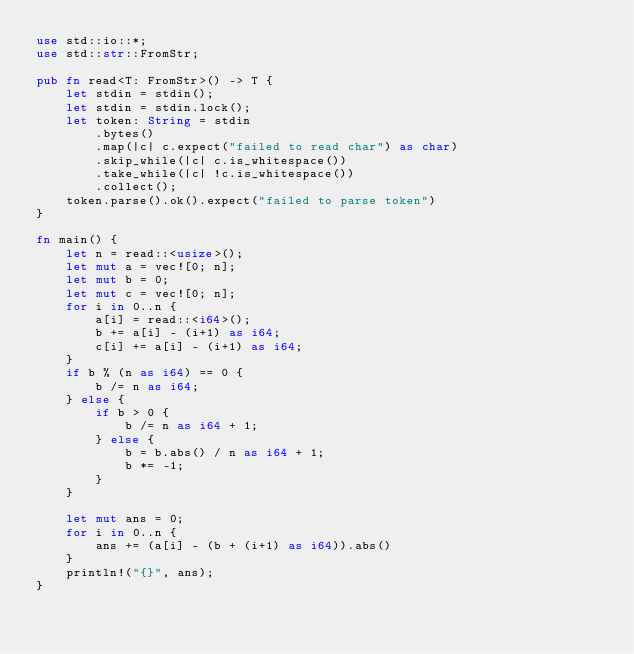Convert code to text. <code><loc_0><loc_0><loc_500><loc_500><_Rust_>use std::io::*;
use std::str::FromStr;

pub fn read<T: FromStr>() -> T {
    let stdin = stdin();
    let stdin = stdin.lock();
    let token: String = stdin
        .bytes()
        .map(|c| c.expect("failed to read char") as char)
        .skip_while(|c| c.is_whitespace())
        .take_while(|c| !c.is_whitespace())
        .collect();
    token.parse().ok().expect("failed to parse token")
}

fn main() {
    let n = read::<usize>();
    let mut a = vec![0; n];
    let mut b = 0;
    let mut c = vec![0; n];
    for i in 0..n {
        a[i] = read::<i64>();
        b += a[i] - (i+1) as i64;
        c[i] += a[i] - (i+1) as i64;
    }
    if b % (n as i64) == 0 {
        b /= n as i64;
    } else {
        if b > 0 {
            b /= n as i64 + 1;
        } else {
            b = b.abs() / n as i64 + 1;
            b *= -1;
        }
    }

    let mut ans = 0;
    for i in 0..n {
        ans += (a[i] - (b + (i+1) as i64)).abs()
    }
    println!("{}", ans);
}</code> 